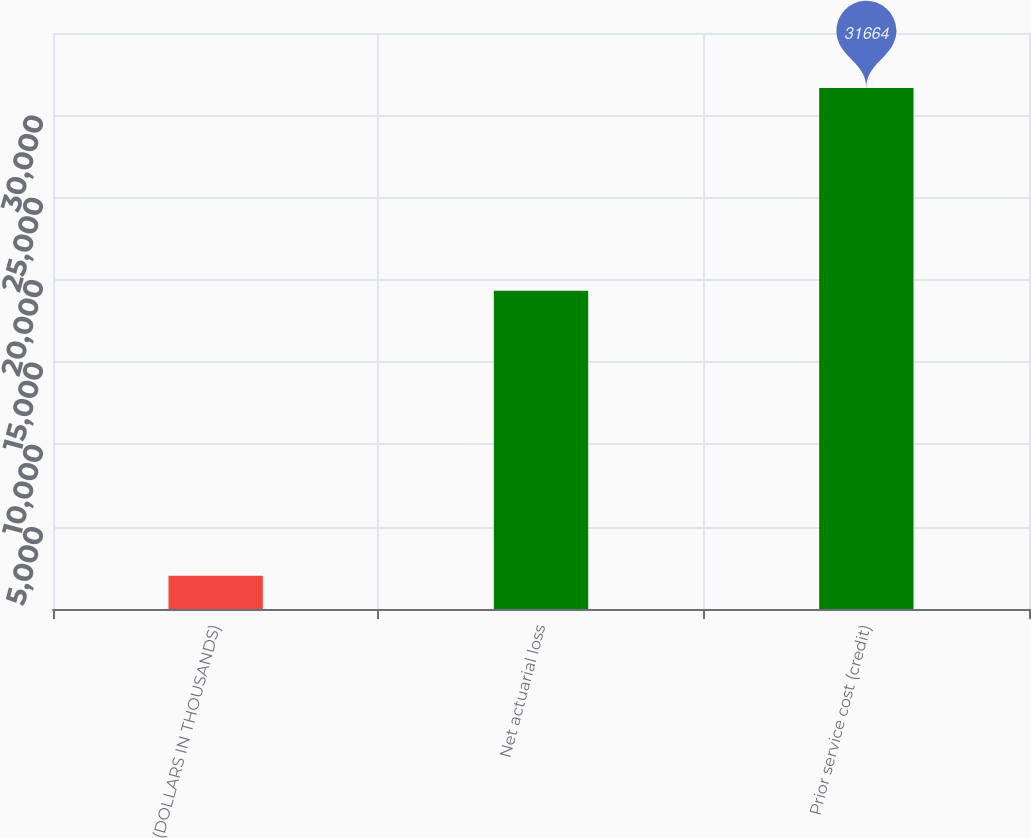Convert chart. <chart><loc_0><loc_0><loc_500><loc_500><bar_chart><fcel>(DOLLARS IN THOUSANDS)<fcel>Net actuarial loss<fcel>Prior service cost (credit)<nl><fcel>2016<fcel>19336<fcel>31664<nl></chart> 